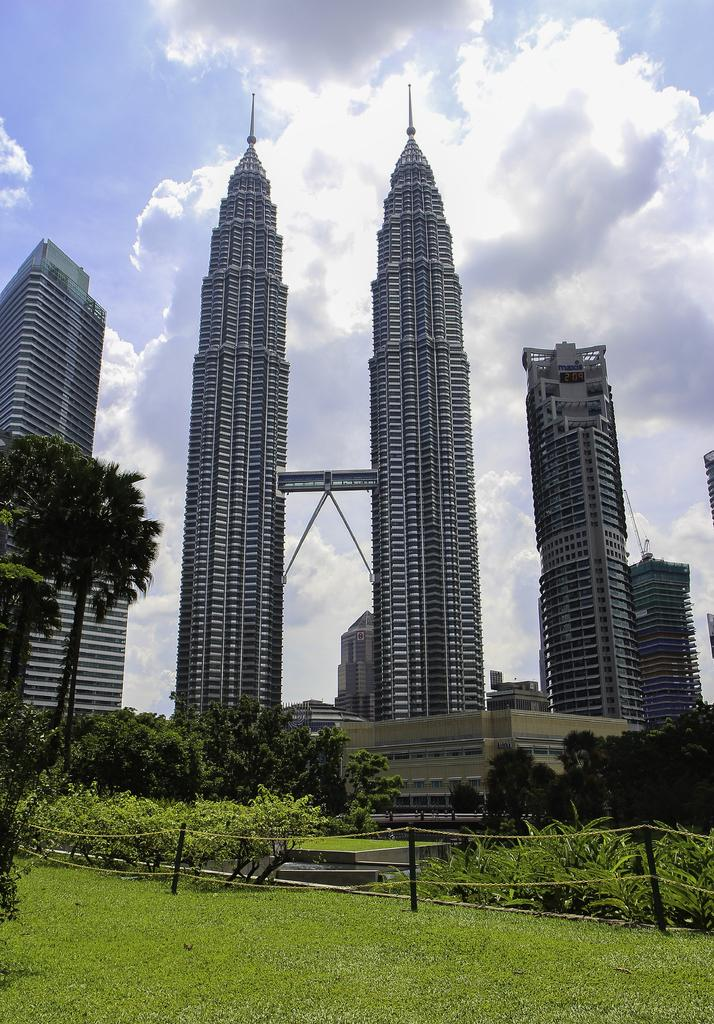What structures are present in the image? There are towers and buildings in the image. What is located in front of the buildings? There are trees, plants, poles, and grass in front of the buildings. What can be seen behind the buildings? The sky is visible behind the buildings. What type of quilt is draped over the buildings in the image? There is no quilt present in the image; it features towers, buildings, trees, plants, poles, grass, and the sky. How many pages can be seen in the image? There are no pages present in the image. 